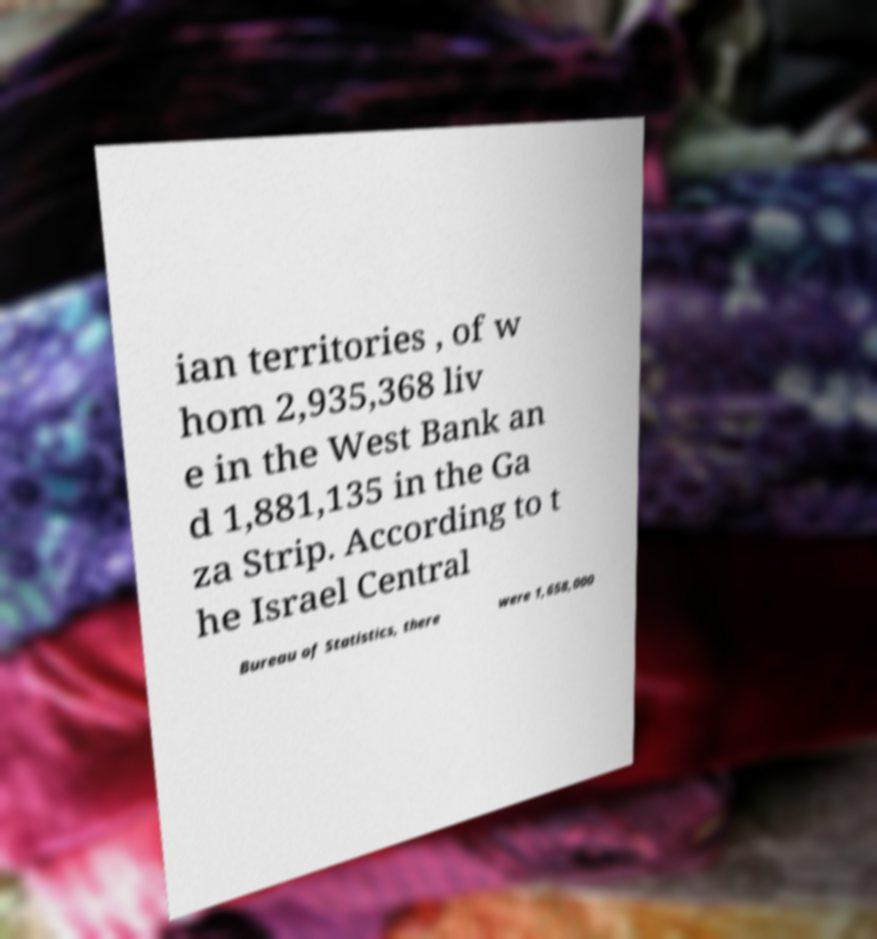Please identify and transcribe the text found in this image. ian territories , of w hom 2,935,368 liv e in the West Bank an d 1,881,135 in the Ga za Strip. According to t he Israel Central Bureau of Statistics, there were 1,658,000 